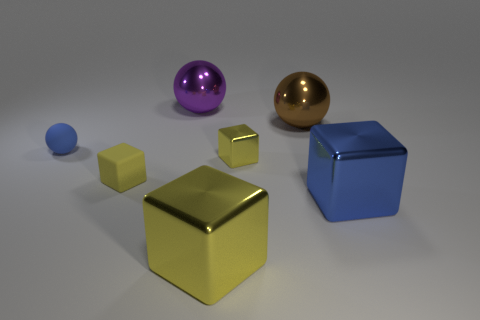Subtract all yellow cubes. How many were subtracted if there are1yellow cubes left? 2 Subtract all gray cylinders. How many yellow blocks are left? 3 Add 3 large yellow blocks. How many objects exist? 10 Subtract all blue blocks. How many blocks are left? 3 Subtract 1 spheres. How many spheres are left? 2 Subtract all blue cubes. How many cubes are left? 3 Subtract all spheres. How many objects are left? 4 Subtract all gray balls. Subtract all brown cylinders. How many balls are left? 3 Subtract all purple balls. Subtract all large purple metallic objects. How many objects are left? 5 Add 1 big metallic cubes. How many big metallic cubes are left? 3 